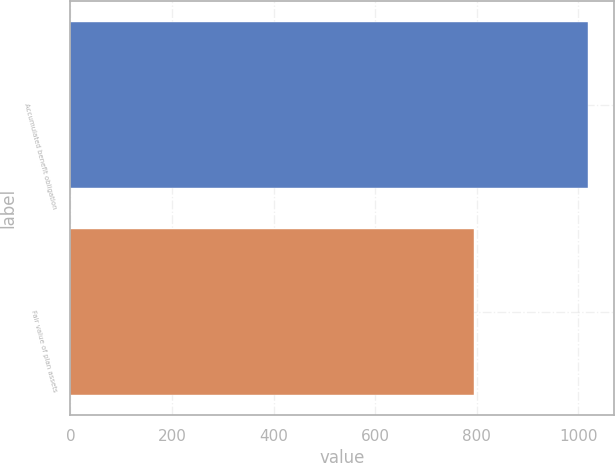<chart> <loc_0><loc_0><loc_500><loc_500><bar_chart><fcel>Accumulated benefit obligation<fcel>Fair value of plan assets<nl><fcel>1018.5<fcel>794.9<nl></chart> 